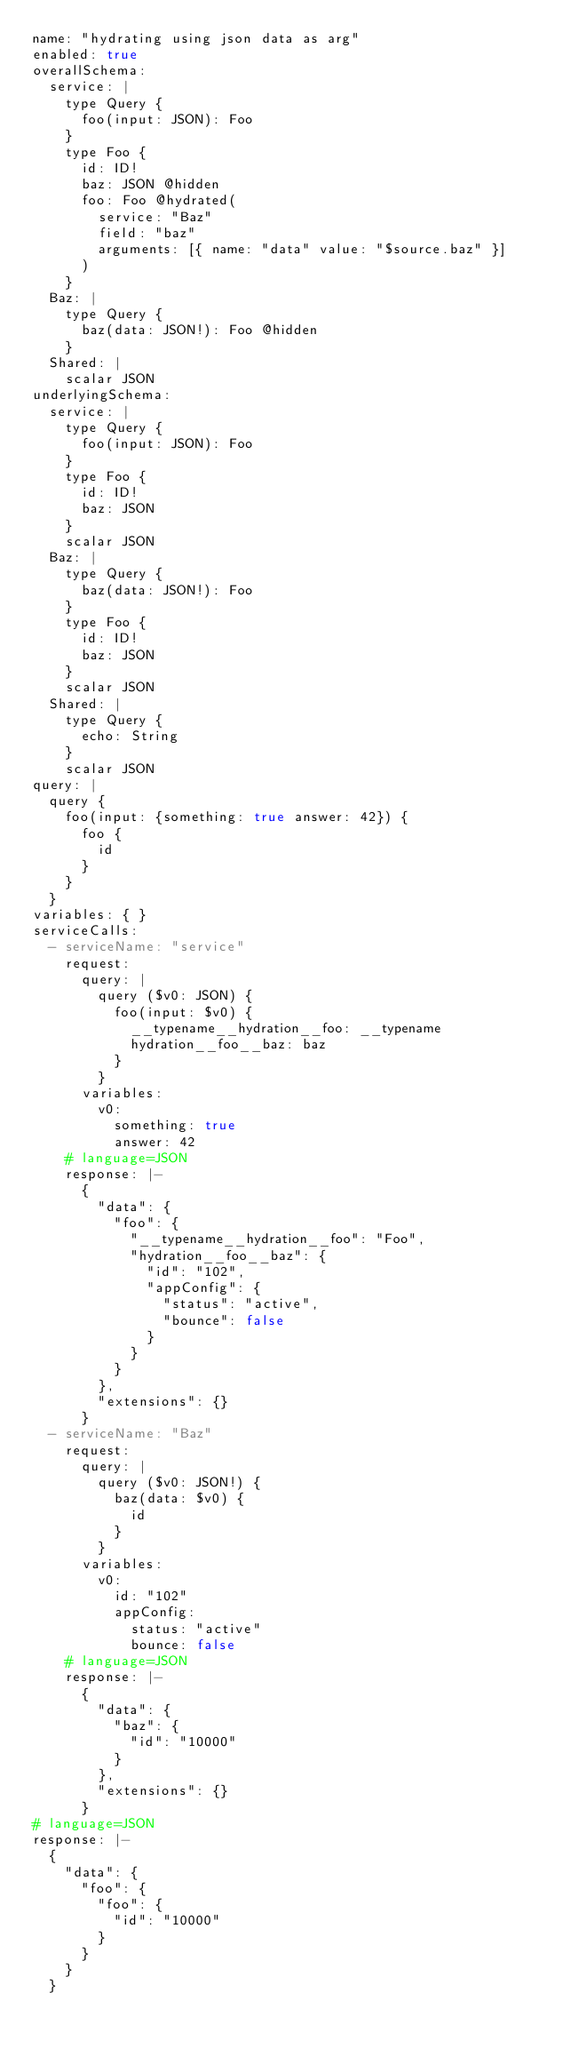<code> <loc_0><loc_0><loc_500><loc_500><_YAML_>name: "hydrating using json data as arg"
enabled: true
overallSchema:
  service: |
    type Query {
      foo(input: JSON): Foo
    }
    type Foo {
      id: ID!
      baz: JSON @hidden
      foo: Foo @hydrated(
        service: "Baz"
        field: "baz"
        arguments: [{ name: "data" value: "$source.baz" }]
      )
    }
  Baz: |
    type Query {
      baz(data: JSON!): Foo @hidden
    }
  Shared: |
    scalar JSON
underlyingSchema:
  service: |
    type Query {
      foo(input: JSON): Foo
    }
    type Foo {
      id: ID!
      baz: JSON
    }
    scalar JSON
  Baz: |
    type Query {
      baz(data: JSON!): Foo
    }
    type Foo {
      id: ID!
      baz: JSON
    }
    scalar JSON
  Shared: |
    type Query {
      echo: String
    }
    scalar JSON
query: |
  query {
    foo(input: {something: true answer: 42}) {
      foo {
        id
      }
    }
  }
variables: { }
serviceCalls:
  - serviceName: "service"
    request:
      query: |
        query ($v0: JSON) {
          foo(input: $v0) {
            __typename__hydration__foo: __typename
            hydration__foo__baz: baz
          }
        }
      variables:
        v0:
          something: true
          answer: 42
    # language=JSON
    response: |-
      {
        "data": {
          "foo": {
            "__typename__hydration__foo": "Foo",
            "hydration__foo__baz": {
              "id": "102",
              "appConfig": {
                "status": "active",
                "bounce": false
              }
            }
          }
        },
        "extensions": {}
      }
  - serviceName: "Baz"
    request:
      query: |
        query ($v0: JSON!) {
          baz(data: $v0) {
            id
          }
        }
      variables:
        v0:
          id: "102"
          appConfig:
            status: "active"
            bounce: false
    # language=JSON
    response: |-
      {
        "data": {
          "baz": {
            "id": "10000"
          }
        },
        "extensions": {}
      }
# language=JSON
response: |-
  {
    "data": {
      "foo": {
        "foo": {
          "id": "10000"
        }
      }
    }
  }
</code> 